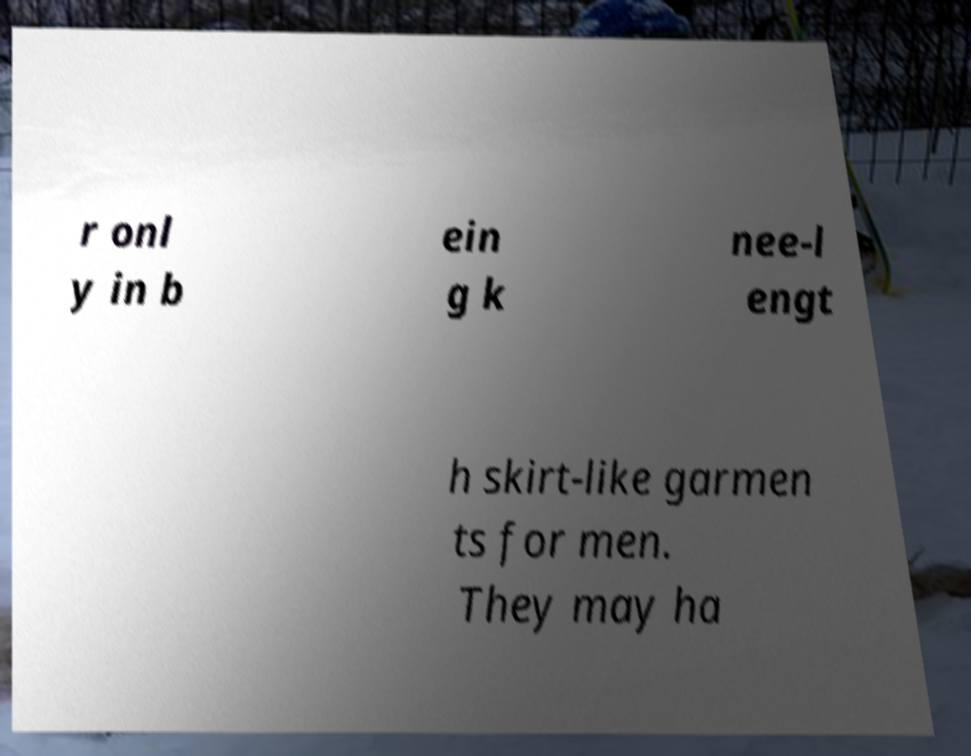I need the written content from this picture converted into text. Can you do that? r onl y in b ein g k nee-l engt h skirt-like garmen ts for men. They may ha 